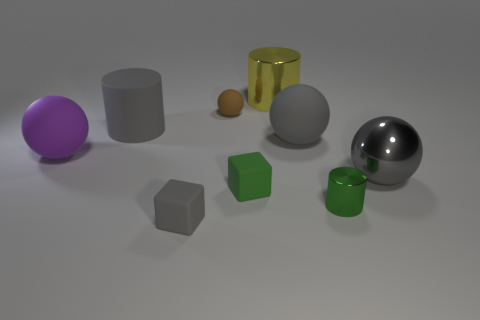There is a rubber cube to the right of the tiny brown rubber thing; is it the same color as the large shiny sphere?
Offer a terse response. No. How many big metal objects are the same shape as the tiny brown rubber thing?
Make the answer very short. 1. How many objects are yellow shiny things that are right of the small brown thing or cylinders that are behind the tiny brown sphere?
Offer a terse response. 1. How many brown things are either big spheres or shiny balls?
Your answer should be very brief. 0. What is the material of the thing that is both on the right side of the small brown thing and in front of the green matte block?
Your response must be concise. Metal. Is the big purple sphere made of the same material as the small cylinder?
Offer a very short reply. No. What number of metal objects are the same size as the brown ball?
Offer a very short reply. 1. Are there an equal number of tiny rubber spheres that are in front of the small shiny cylinder and green blocks?
Offer a very short reply. No. How many rubber objects are in front of the gray metal thing and left of the big matte cylinder?
Provide a succinct answer. 0. Is the shape of the large gray rubber thing that is on the left side of the big shiny cylinder the same as  the yellow shiny object?
Provide a short and direct response. Yes. 